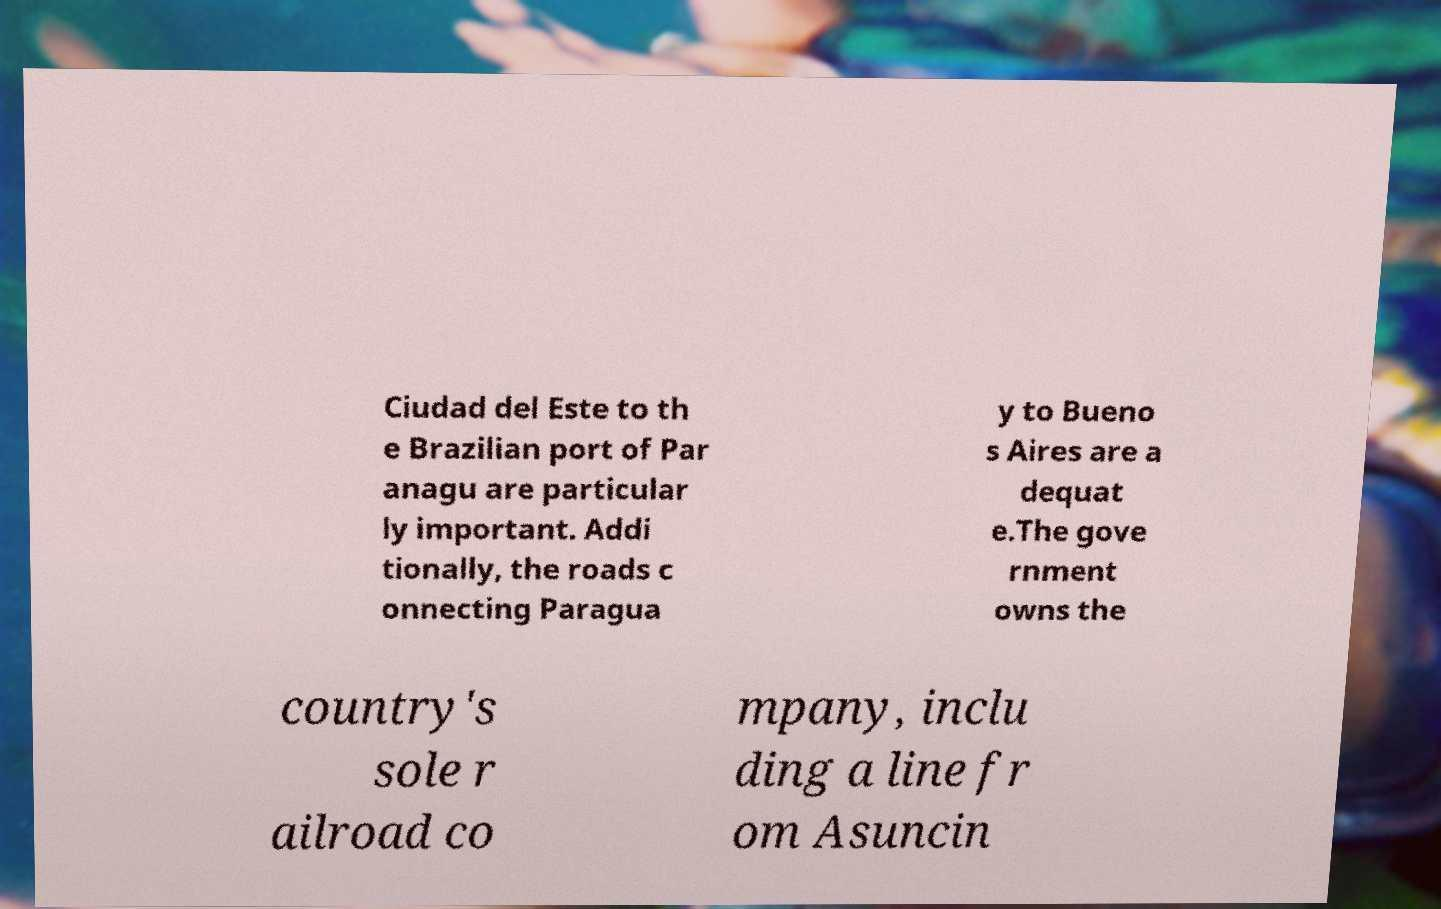Please read and relay the text visible in this image. What does it say? Ciudad del Este to th e Brazilian port of Par anagu are particular ly important. Addi tionally, the roads c onnecting Paragua y to Bueno s Aires are a dequat e.The gove rnment owns the country's sole r ailroad co mpany, inclu ding a line fr om Asuncin 